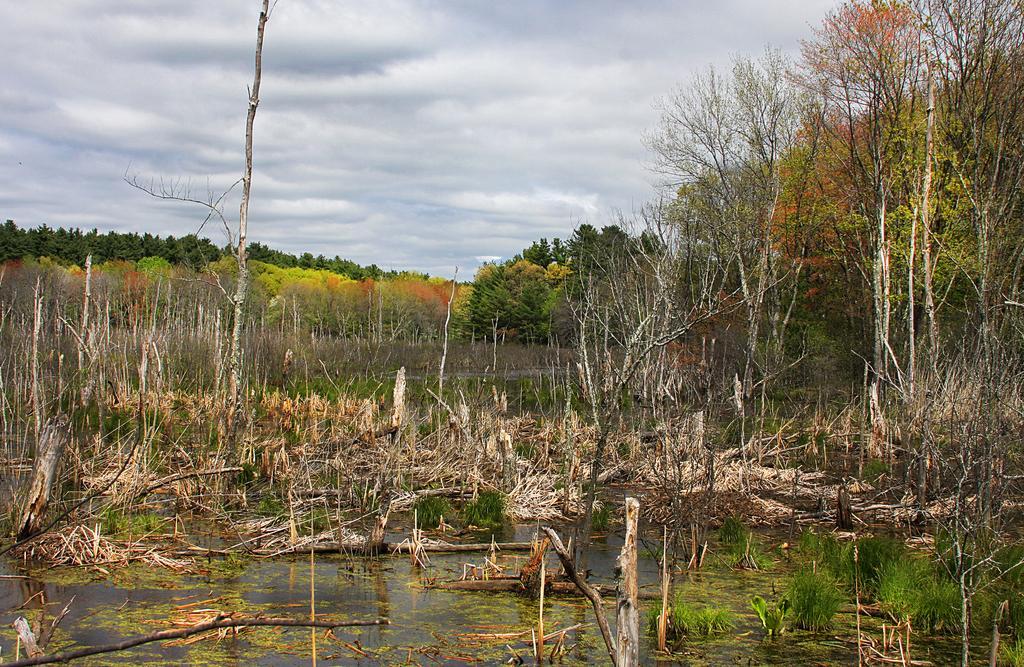In one or two sentences, can you explain what this image depicts? In this image we can see water, wooden sticks, small plants, trees and the cloudy sky in the background. 